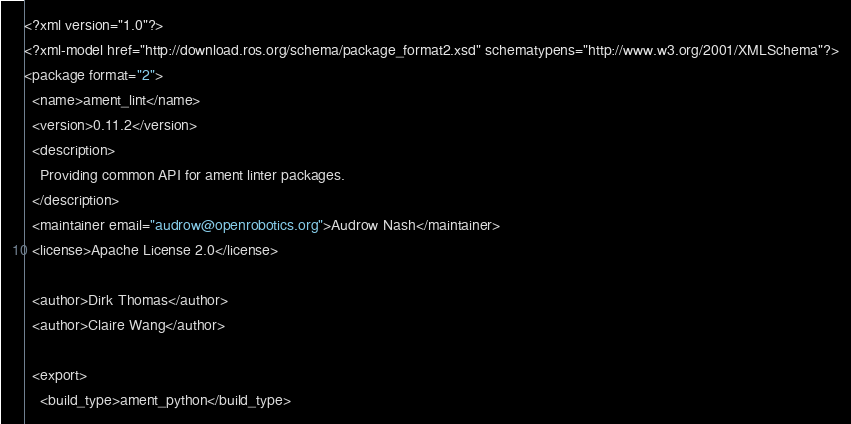Convert code to text. <code><loc_0><loc_0><loc_500><loc_500><_XML_><?xml version="1.0"?>
<?xml-model href="http://download.ros.org/schema/package_format2.xsd" schematypens="http://www.w3.org/2001/XMLSchema"?>
<package format="2">
  <name>ament_lint</name>
  <version>0.11.2</version>
  <description>
    Providing common API for ament linter packages.
  </description>
  <maintainer email="audrow@openrobotics.org">Audrow Nash</maintainer>
  <license>Apache License 2.0</license>

  <author>Dirk Thomas</author>
  <author>Claire Wang</author>

  <export>
    <build_type>ament_python</build_type></code> 